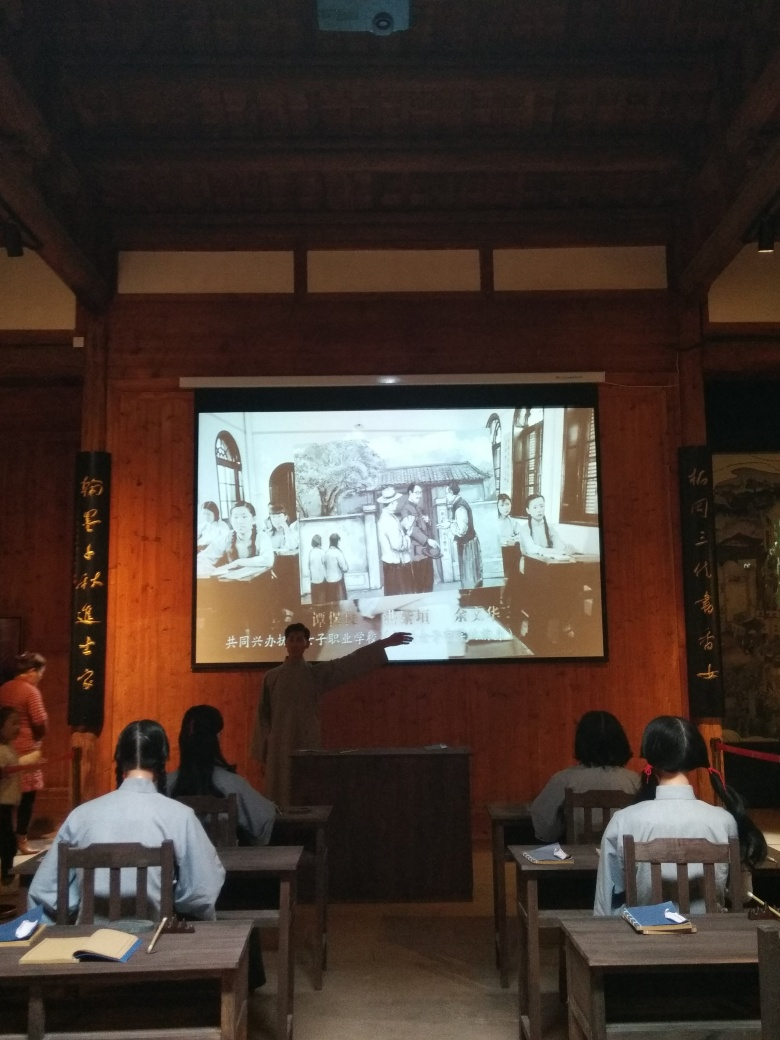Can you describe what's happening in the image? The image depicts a classroom setting in which a lecturer is presenting a historical image projected on a screen, likely discussing its content with the attendees. The audience, dressed in traditional attire, appears to be engaged in the educational activity, taking notes and listening attentively. What kind of historical period do you think the projected image represents? The projected image appears to represent an East Asian historical setting, potentially showcasing a scene from daily life in a period which might date back several centuries, indicated by the traditional architecture and clothing styles present in the scene. 